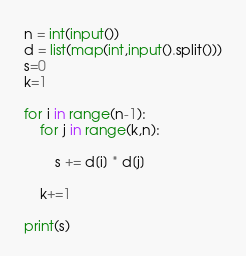Convert code to text. <code><loc_0><loc_0><loc_500><loc_500><_Python_>n = int(input())
d = list(map(int,input().split()))
s=0
k=1

for i in range(n-1):
    for j in range(k,n):
        
        s += d[i] * d[j]
         
    k+=1
    
print(s)</code> 